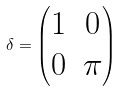Convert formula to latex. <formula><loc_0><loc_0><loc_500><loc_500>\delta = \begin{pmatrix} 1 & 0 \\ 0 & \pi \\ \end{pmatrix}</formula> 